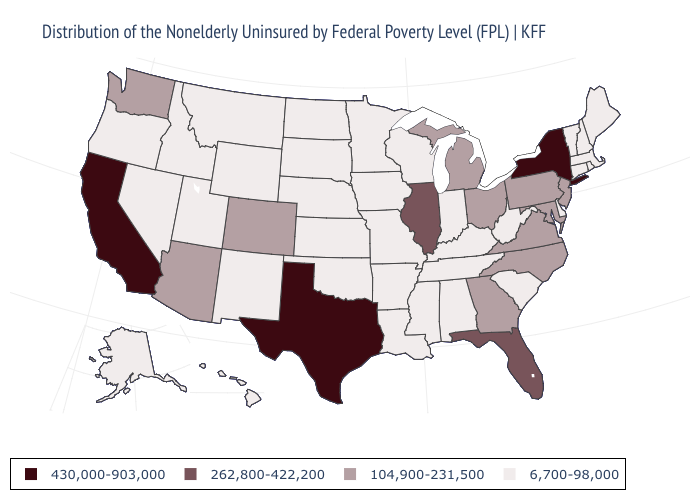What is the value of Delaware?
Answer briefly. 6,700-98,000. Name the states that have a value in the range 262,800-422,200?
Concise answer only. Florida, Illinois. Which states have the lowest value in the USA?
Be succinct. Alabama, Alaska, Arkansas, Connecticut, Delaware, Hawaii, Idaho, Indiana, Iowa, Kansas, Kentucky, Louisiana, Maine, Massachusetts, Minnesota, Mississippi, Missouri, Montana, Nebraska, Nevada, New Hampshire, New Mexico, North Dakota, Oklahoma, Oregon, Rhode Island, South Carolina, South Dakota, Tennessee, Utah, Vermont, West Virginia, Wisconsin, Wyoming. Name the states that have a value in the range 262,800-422,200?
Give a very brief answer. Florida, Illinois. Among the states that border Rhode Island , which have the highest value?
Answer briefly. Connecticut, Massachusetts. Among the states that border Delaware , which have the lowest value?
Keep it brief. Maryland, New Jersey, Pennsylvania. What is the highest value in states that border Utah?
Write a very short answer. 104,900-231,500. Name the states that have a value in the range 430,000-903,000?
Write a very short answer. California, New York, Texas. What is the highest value in states that border Wisconsin?
Answer briefly. 262,800-422,200. Name the states that have a value in the range 430,000-903,000?
Quick response, please. California, New York, Texas. Which states have the lowest value in the South?
Give a very brief answer. Alabama, Arkansas, Delaware, Kentucky, Louisiana, Mississippi, Oklahoma, South Carolina, Tennessee, West Virginia. Does New Jersey have the lowest value in the USA?
Give a very brief answer. No. Name the states that have a value in the range 262,800-422,200?
Keep it brief. Florida, Illinois. Does the map have missing data?
Quick response, please. No. 